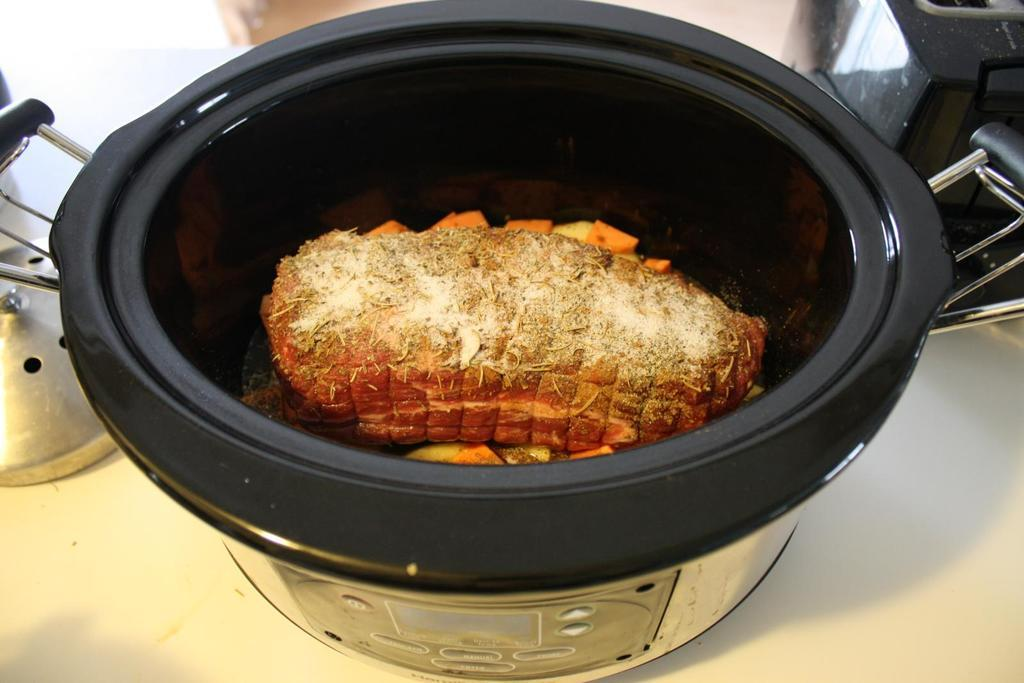What is present in the image that can hold items? There is a bowl in the image that can hold items. What is the bowl placed on? The bowl is on an object. What type of food items are in the bowl? There are food items in the bowl. What else can be seen in the image besides the bowl and food items? There are other things visible behind the bowl. How many chickens are sitting on the food items in the bowl? There are no chickens present in the image, so it is not possible to determine how many would be sitting on the food items in the bowl. 